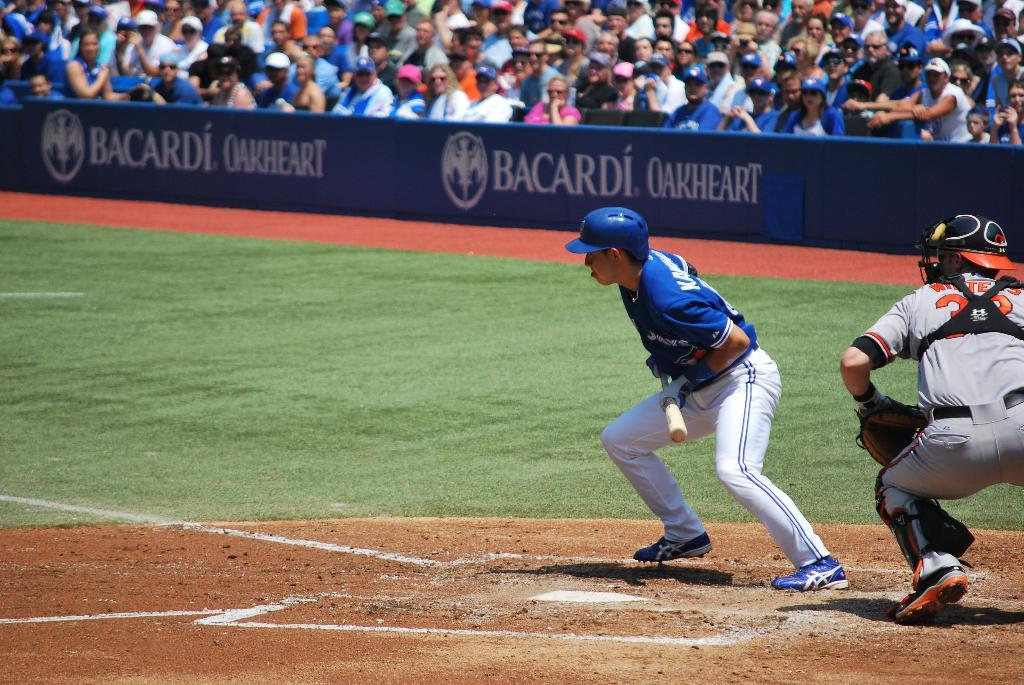<image>
Summarize the visual content of the image. Baseball game in a stadium that has the banner which says "Bacardi". 